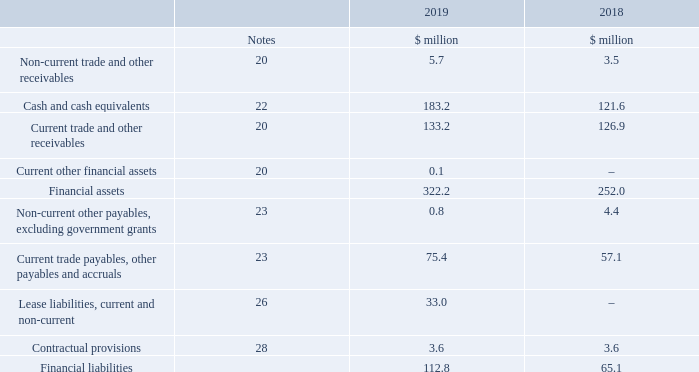30. Financial instruments and financial risk management
The main purpose of the Group’s financial instruments, other than trade and other receivables, trade and other payables, contractual provisions and lease liabilities, is to fund the Group’s liquidity requirements.
All of the Group’s financial assets and liabilities are categorised as financial assets/liabilities stated at amortised cost, except for forward foreign currency exchange contracts, included within current other financial assets, that are designated as financial assets at fair value through profit or loss and corporate owned life insurance, amounting to $3.0 million (2018 $2.4 million), included within non-current trade and other receivables, that is designated as financial assets at fair value through profit or loss. These are shown in the below table:
The Group enters into derivative transactions, forward foreign currency exchange contracts, for the management of the Group’s foreign currency exposures when deemed appropriate.
The key objective of the Group’s treasury department is to manage the financial risks of the business and to ensure that sufficient liquidity is available to the Group. All treasury activity operates within a formal control framework. The Board has approved treasury policies and guidelines and periodically reviews treasury activities. Additionally, it is the Group’s policy that speculative treasury transactions are expressly forbidden.
What is the total financial liabilities in 2019?
Answer scale should be: million. 112.8. What is the key objective of the Group's treasury department? To manage the financial risks of the business and to ensure that sufficient liquidity is available to the group. What are the components under Financial assets? Non-current trade and other receivables, cash and cash equivalents, current trade and other receivables, current other financial assets. In which year was the amount of Non-current trade and other receivables larger? 5.7>3.5
Answer: 2019. What was the change in Non-current trade and other receivables?
Answer scale should be: million. 5.7-3.5
Answer: 2.2. What was the percentage change in Non-current trade and other receivables?
Answer scale should be: percent. (5.7-3.5)/3.5
Answer: 62.86. 